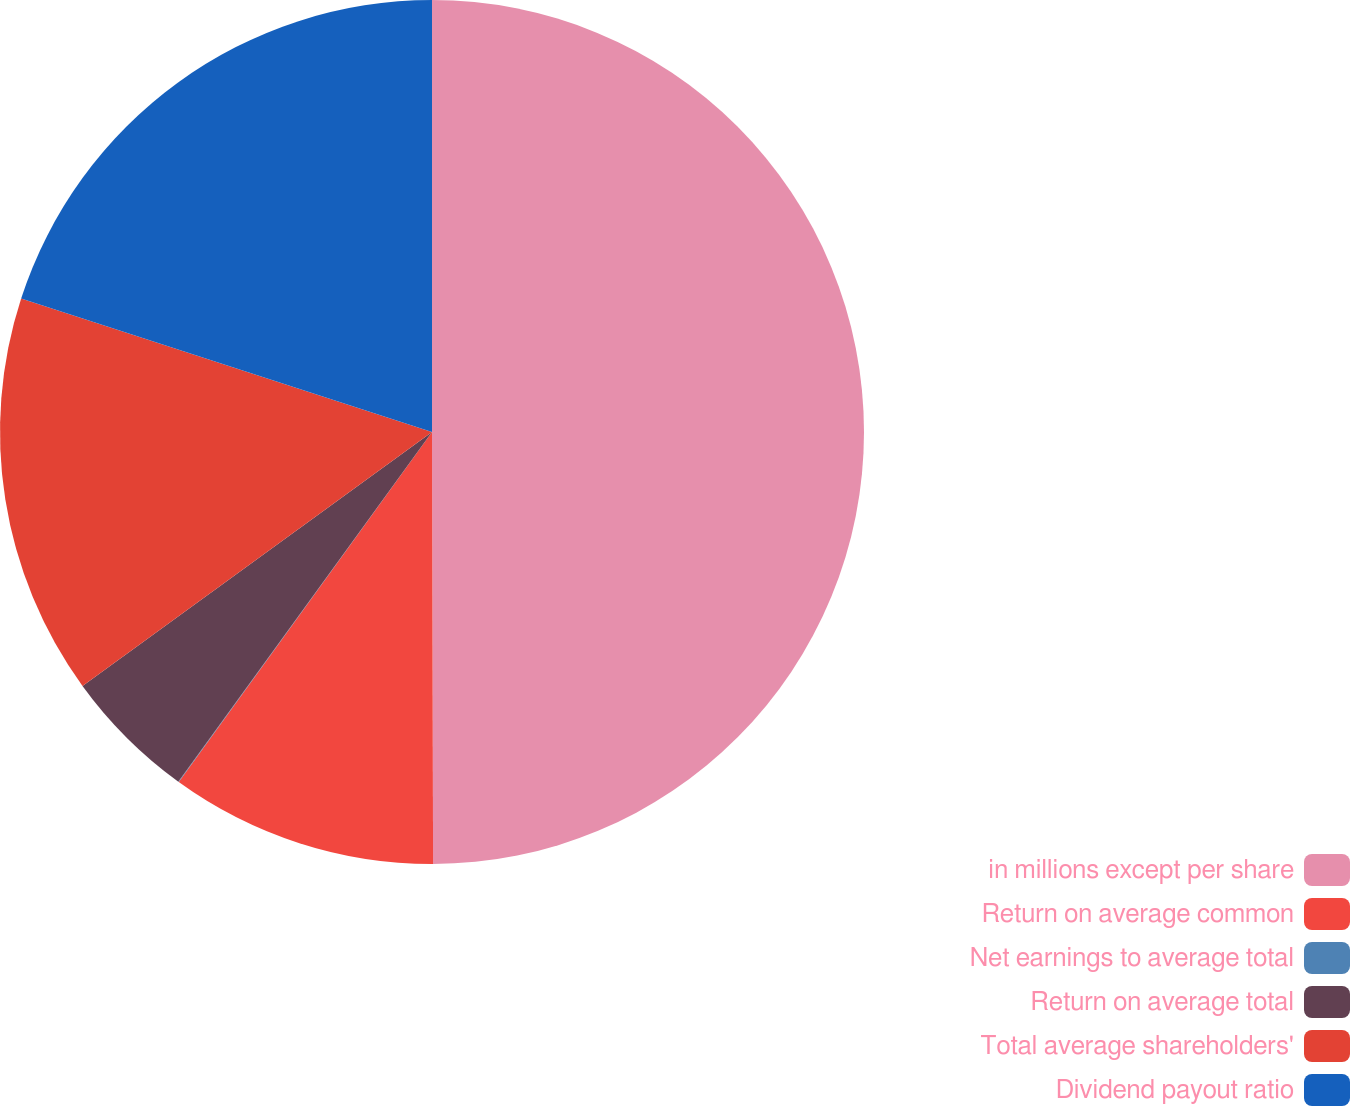<chart> <loc_0><loc_0><loc_500><loc_500><pie_chart><fcel>in millions except per share<fcel>Return on average common<fcel>Net earnings to average total<fcel>Return on average total<fcel>Total average shareholders'<fcel>Dividend payout ratio<nl><fcel>49.96%<fcel>10.01%<fcel>0.02%<fcel>5.01%<fcel>15.0%<fcel>20.0%<nl></chart> 